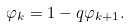Convert formula to latex. <formula><loc_0><loc_0><loc_500><loc_500>\varphi _ { k } = 1 - q \varphi _ { k + 1 } .</formula> 